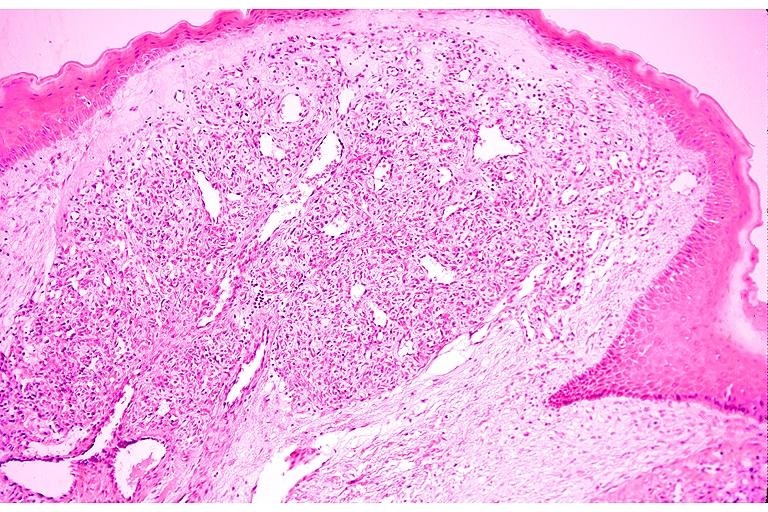s feet present?
Answer the question using a single word or phrase. No 